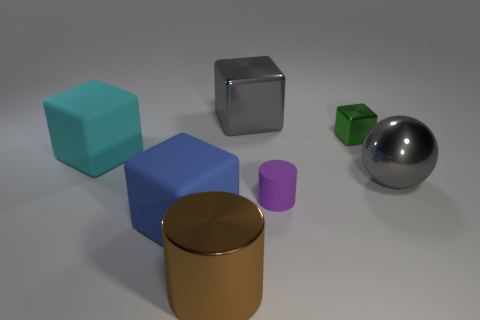Subtract all big cyan rubber blocks. How many blocks are left? 3 Subtract 1 cubes. How many cubes are left? 3 Subtract all cyan cubes. How many cubes are left? 3 Add 1 gray blocks. How many objects exist? 8 Subtract all brown blocks. Subtract all brown cylinders. How many blocks are left? 4 Subtract all balls. How many objects are left? 6 Subtract 0 cyan cylinders. How many objects are left? 7 Subtract all large purple rubber cylinders. Subtract all gray spheres. How many objects are left? 6 Add 2 gray spheres. How many gray spheres are left? 3 Add 6 tiny red spheres. How many tiny red spheres exist? 6 